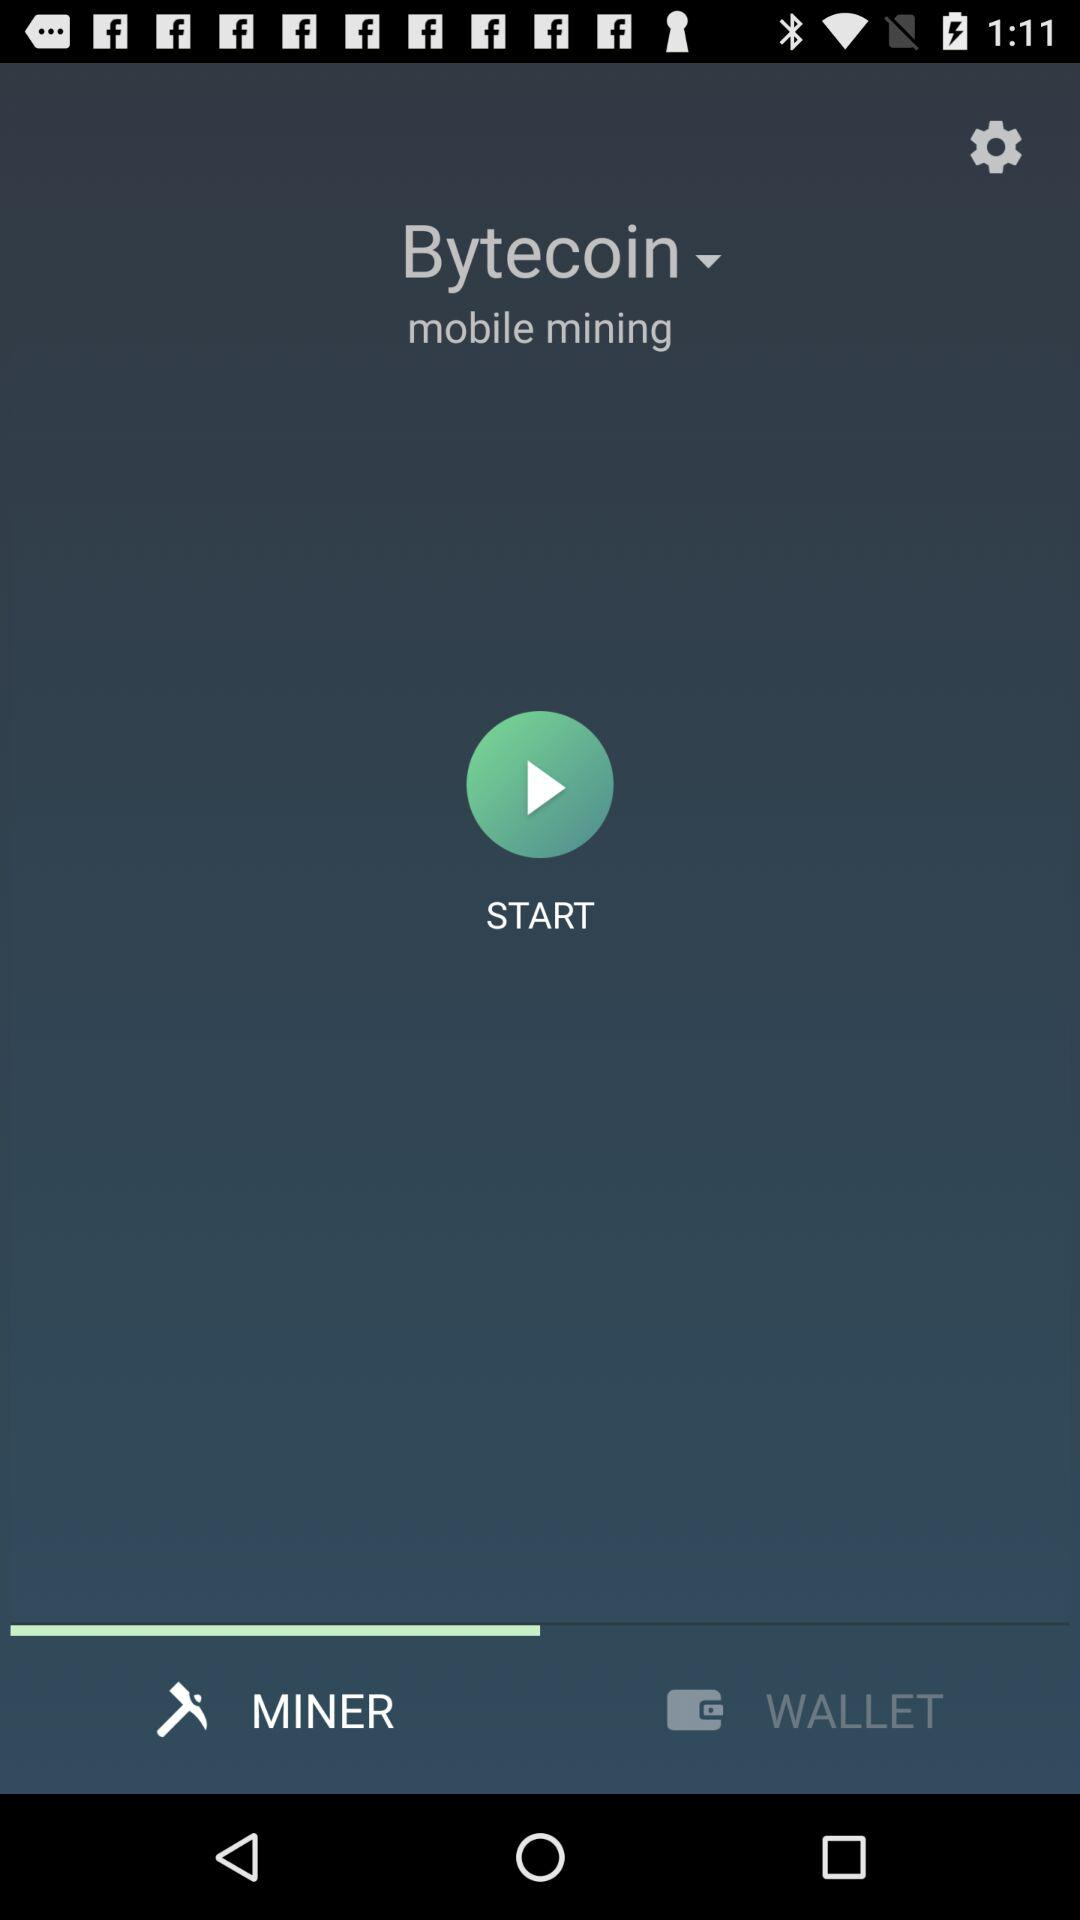Which option has been selected for "mobile mining"? The selected option is "Bytecoin". 